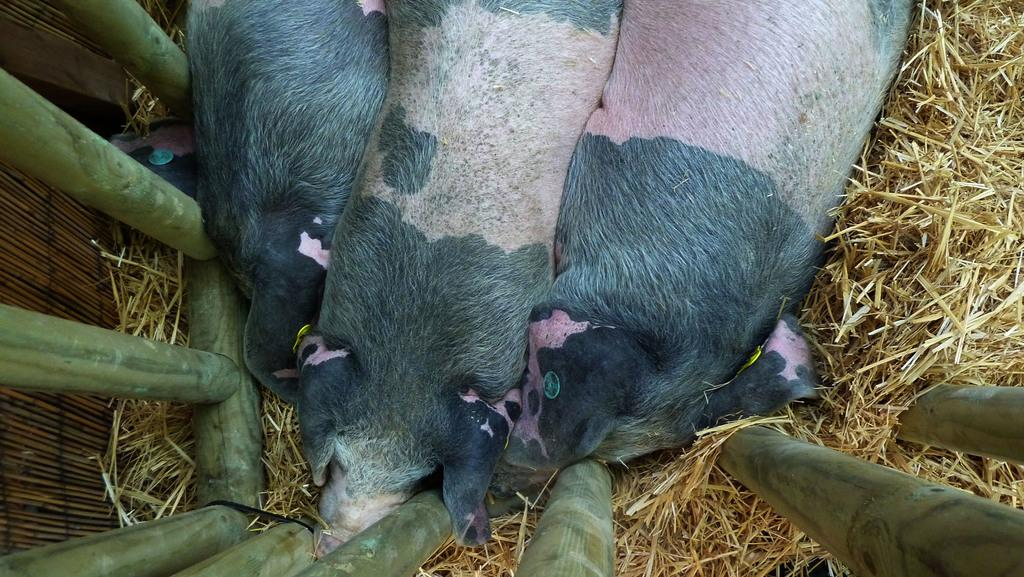What type of living organisms are present in the image? There are animals in the image. What colors can be seen on the animals? The animals have black, white, and pink colors. What type of vegetation is visible in the image? There is dry grass visible in the image. What other objects can be seen in the image? There are green poles in the image. What sound does the clam make in the image? There is no clam present in the image, so it is not possible to determine the sound it might make. 